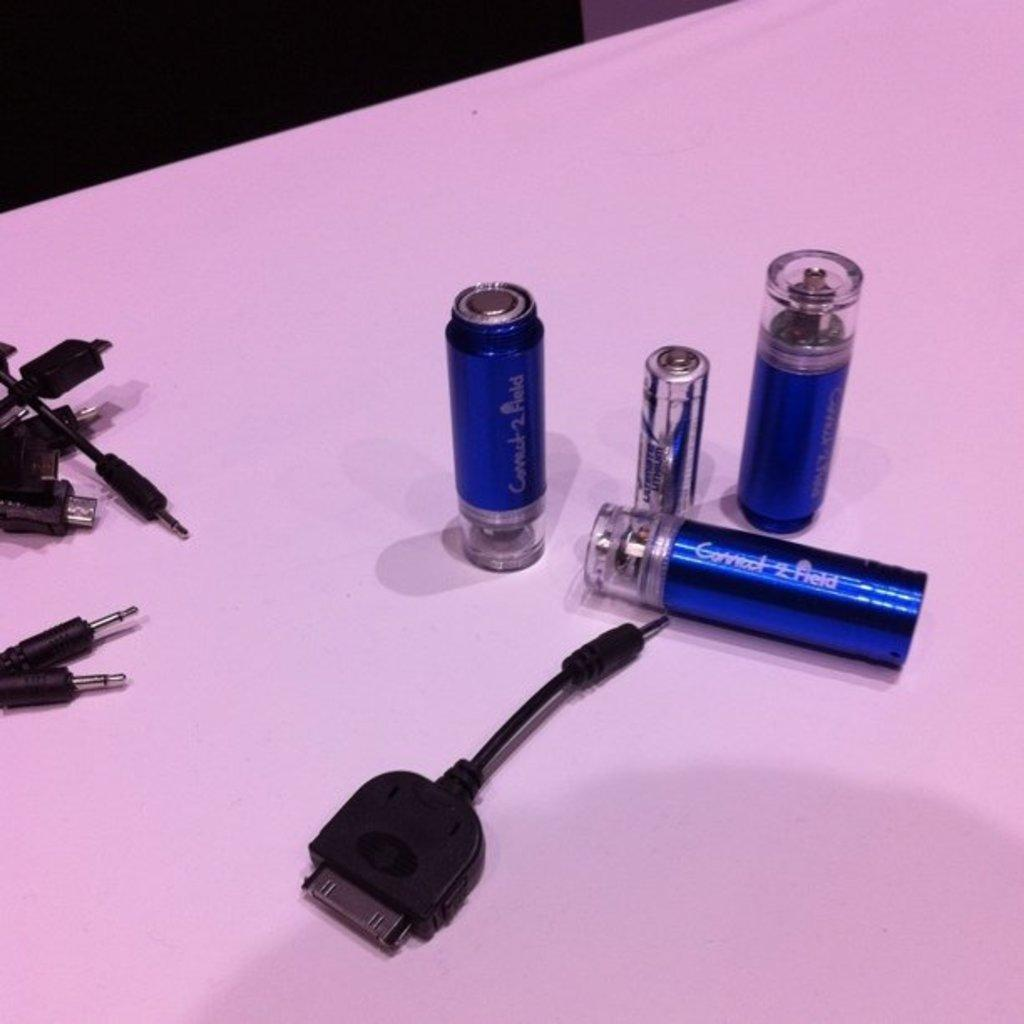Provide a one-sentence caption for the provided image. Three Connect 2 Field canisters sit on a table. 